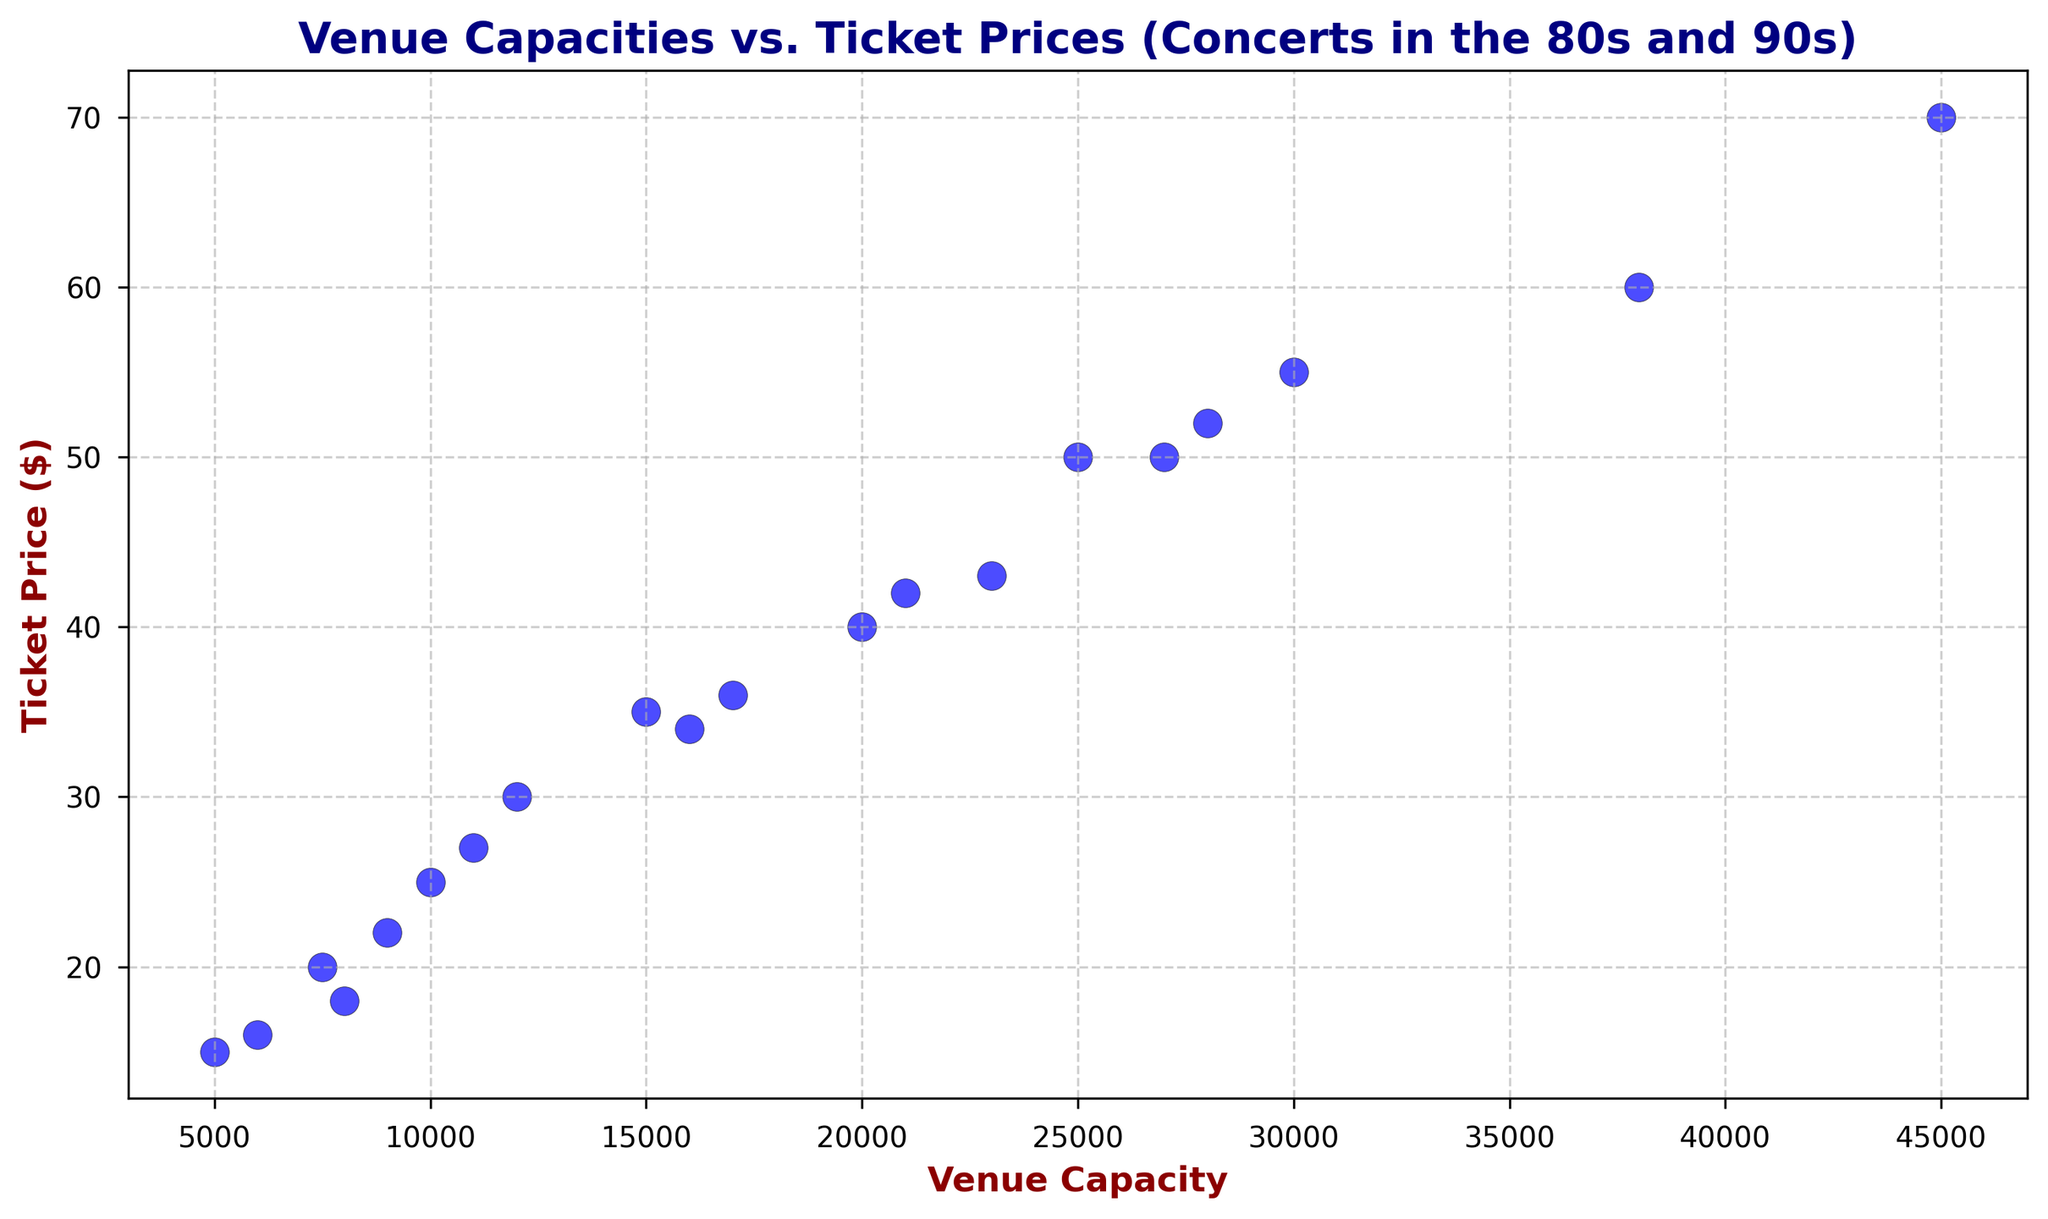What is the general trend between venue capacity and ticket price? By looking at the scatter plot, it's evident that as the venue capacity increases, the ticket price also tends to increase. This pattern suggests a positive correlation between the two variables.
Answer: Positive correlation Which point represents the highest ticket price and what is its corresponding venue capacity? The highest ticket price in the scatter plot is $70, and its corresponding venue capacity is 45,000. This can be found by looking for the highest point on the y-axis and noting its x-axis value.
Answer: $70 at 45,000 capacity What is the difference in ticket price between the smallest and largest venue capacities? The smallest venue capacity in the data is 5,000 and its ticket price is $15, while the largest venue capacity is 45,000 with a ticket price of $70. The difference is $70 - $15 = $55.
Answer: $55 Between the venue capacities of 5,000 and 10,000, which has the higher average ticket price? Average ticket price for 5,000 and 6,000 capacities = ($15 + $16) / 2 = $15.5. Average ticket price for 7,500, 8,000, and 9,000 capacities = ($20 + $18 + $22) / 3 ≈ $20. The higher average ticket price is for capacities 7,500 to 9,000.
Answer: 7,500 to 9,000 capacities have a higher average ticket price What’s the median ticket price for venues with a capacity of 20,000 or more? The ticket prices for venues with capacities of 20,000 or more are $40, $50, $60, $70, $43, $42, $52, and $50. Arranging these in ascending order: $40, $42, $43, $50, $50, $52, $60, $70. The median is the average of the 4th and 5th values: ($50 + $50) / 2 = $50.
Answer: $50 Is there any venue capacity that has an equal ticket price to another capacity in the plot? Yes, there are two capacities that both have a ticket price of $50: the venue capacities of 25,000 and 27,000.
Answer: Yes, 25,000 and 27,000 What is the average ticket price for all the venues shown in the plot? Summing up all ticket prices: $15 + $20 + $25 + $35 + $30 + $40 + $18 + $50 + $36 + $16 + $55 + $60 + $70 + $43 + $27 + $42 + $34 + $52 + $22 + $50 = $710. The total number of data points is 20, so the average is $710 / 20 = $35.5.
Answer: $35.5 Which data point represents the smallest venue capacity, and what are its ticket price and capacity? The smallest venue capacity is 5,000 with a corresponding ticket price of $15. This point can be identified as the leftmost point on the x-axis.
Answer: $15 at 5,000 capacity How does the ticket price vary for venues with capacities between 10,000 and 20,000? The ticket prices for venues with capacities between 10,000 and 20,000 are: $27, $30, $34, $35, $36, and $42. These values show a range from $27 to $42, depicting a moderate increase.
Answer: $27 to $42 